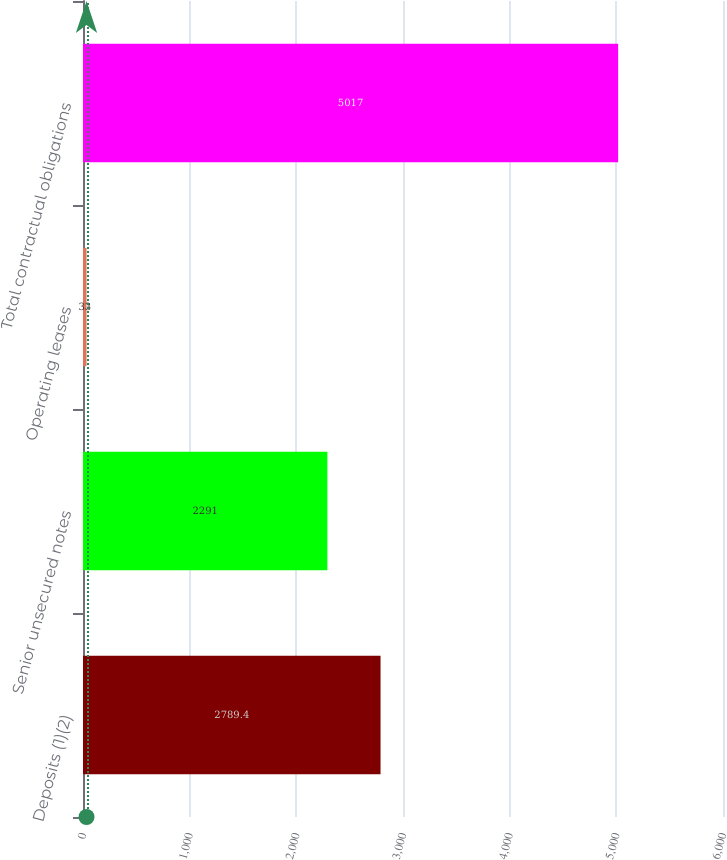Convert chart. <chart><loc_0><loc_0><loc_500><loc_500><bar_chart><fcel>Deposits (1)(2)<fcel>Senior unsecured notes<fcel>Operating leases<fcel>Total contractual obligations<nl><fcel>2789.4<fcel>2291<fcel>33<fcel>5017<nl></chart> 